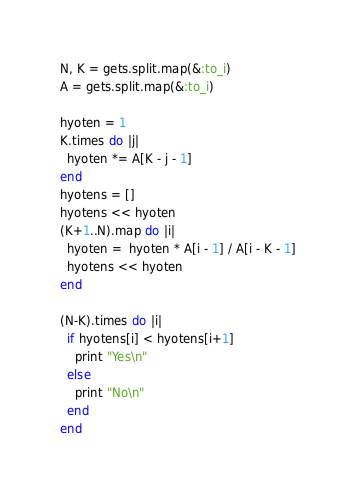Convert code to text. <code><loc_0><loc_0><loc_500><loc_500><_Ruby_>N, K = gets.split.map(&:to_i)
A = gets.split.map(&:to_i)

hyoten = 1
K.times do |j|
  hyoten *= A[K - j - 1]
end
hyotens = []
hyotens << hyoten
(K+1..N).map do |i|
  hyoten =  hyoten * A[i - 1] / A[i - K - 1]
  hyotens << hyoten
end

(N-K).times do |i|
  if hyotens[i] < hyotens[i+1]
    print "Yes\n"
  else
    print "No\n"
  end
end</code> 